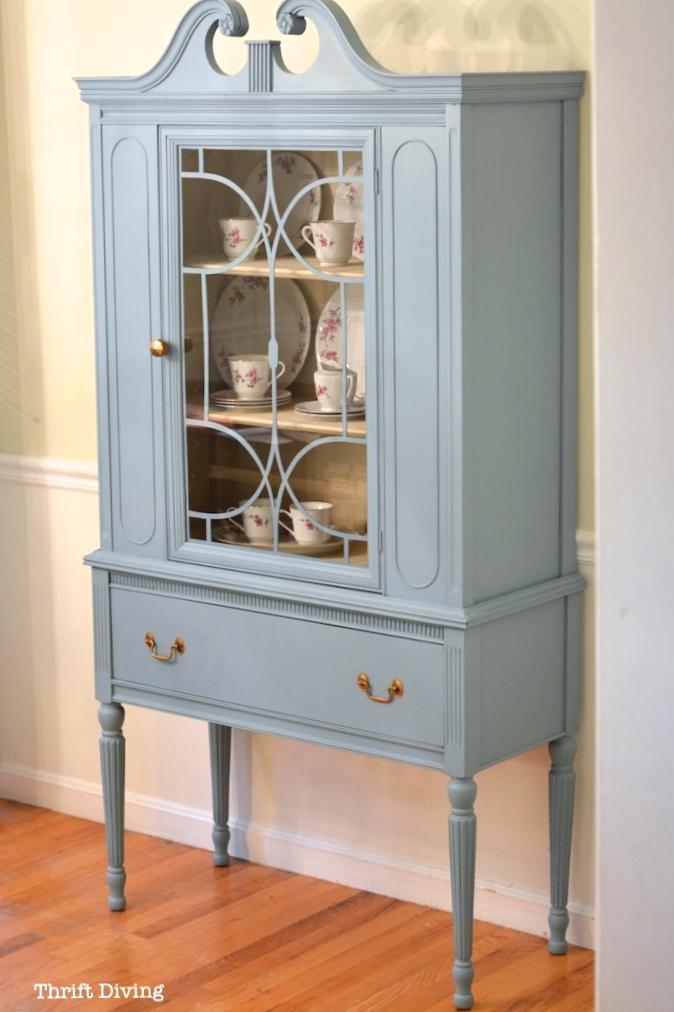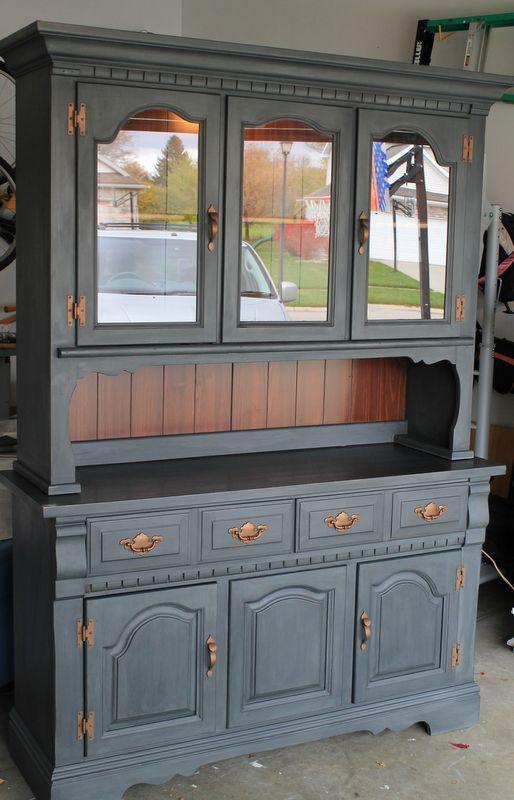The first image is the image on the left, the second image is the image on the right. Considering the images on both sides, is "There are gray diningroom hutches" valid? Answer yes or no. Yes. The first image is the image on the left, the second image is the image on the right. Evaluate the accuracy of this statement regarding the images: "One image features a cabinet with a curved top detail instead of a completely flat top.". Is it true? Answer yes or no. Yes. 